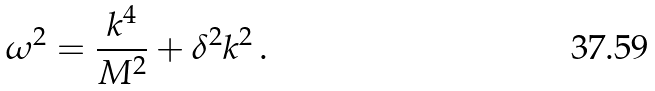Convert formula to latex. <formula><loc_0><loc_0><loc_500><loc_500>\omega ^ { 2 } = \frac { k ^ { 4 } } { M ^ { 2 } } + \delta ^ { 2 } k ^ { 2 } \, .</formula> 